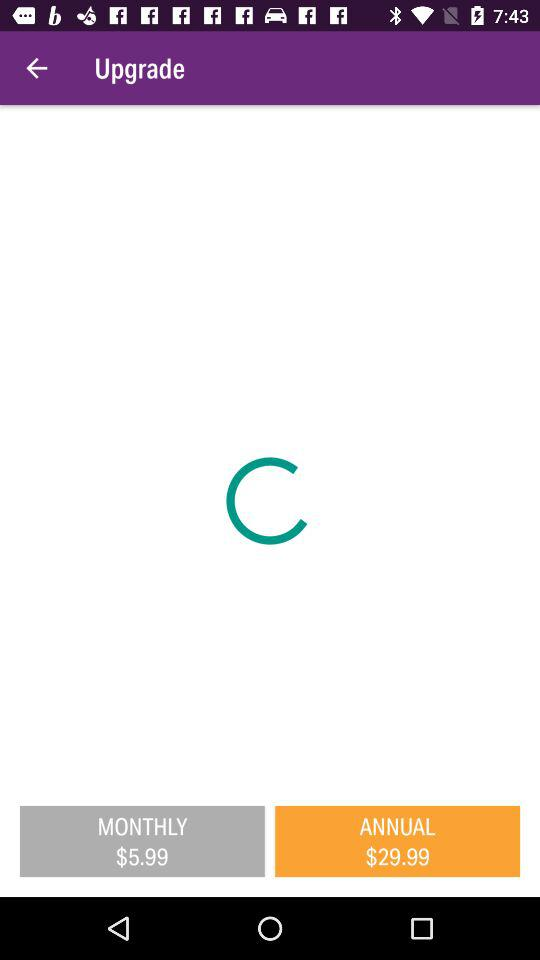What is the selected option? The selected option is "ANNUAL $29.99". 